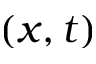<formula> <loc_0><loc_0><loc_500><loc_500>( x , t )</formula> 